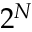Convert formula to latex. <formula><loc_0><loc_0><loc_500><loc_500>2 ^ { N }</formula> 